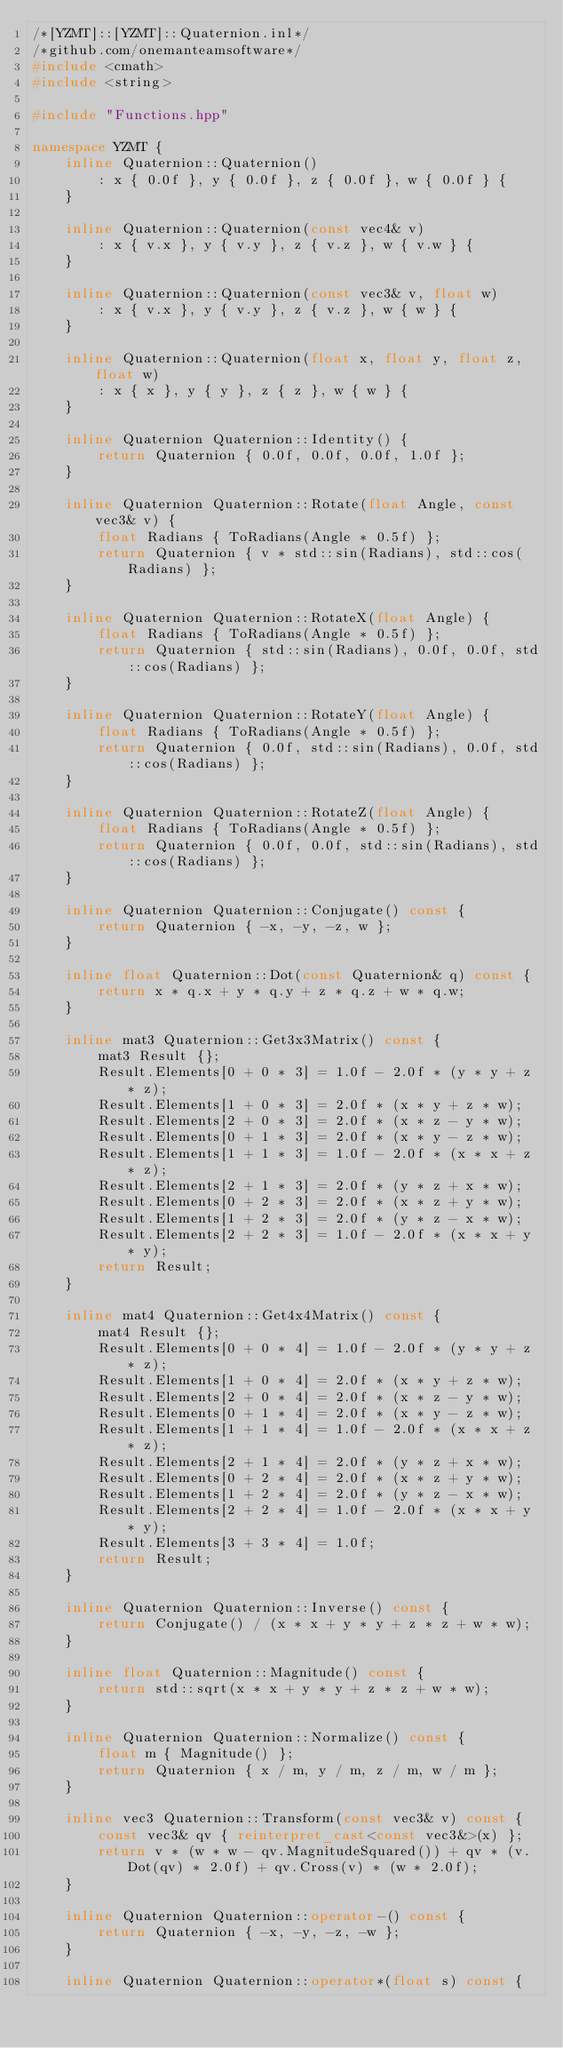Convert code to text. <code><loc_0><loc_0><loc_500><loc_500><_C++_>/*[YZMT]::[YZMT]::Quaternion.inl*/
/*github.com/onemanteamsoftware*/
#include <cmath>
#include <string>

#include "Functions.hpp"

namespace YZMT {
    inline Quaternion::Quaternion()
        : x { 0.0f }, y { 0.0f }, z { 0.0f }, w { 0.0f } {
    }
    
    inline Quaternion::Quaternion(const vec4& v)
        : x { v.x }, y { v.y }, z { v.z }, w { v.w } {
    }
    
    inline Quaternion::Quaternion(const vec3& v, float w)
        : x { v.x }, y { v.y }, z { v.z }, w { w } {
    }
    
    inline Quaternion::Quaternion(float x, float y, float z, float w)
        : x { x }, y { y }, z { z }, w { w } {
    }
    
    inline Quaternion Quaternion::Identity() {
        return Quaternion { 0.0f, 0.0f, 0.0f, 1.0f };
    }
    
    inline Quaternion Quaternion::Rotate(float Angle, const vec3& v) {
        float Radians { ToRadians(Angle * 0.5f) };
        return Quaternion { v * std::sin(Radians), std::cos(Radians) };
    }
    
    inline Quaternion Quaternion::RotateX(float Angle) {
        float Radians { ToRadians(Angle * 0.5f) };
        return Quaternion { std::sin(Radians), 0.0f, 0.0f, std::cos(Radians) };
    }
    
    inline Quaternion Quaternion::RotateY(float Angle) {
        float Radians { ToRadians(Angle * 0.5f) };
        return Quaternion { 0.0f, std::sin(Radians), 0.0f, std::cos(Radians) };
    }
    
    inline Quaternion Quaternion::RotateZ(float Angle) {
        float Radians { ToRadians(Angle * 0.5f) };
        return Quaternion { 0.0f, 0.0f, std::sin(Radians), std::cos(Radians) };
    }
    
    inline Quaternion Quaternion::Conjugate() const {
        return Quaternion { -x, -y, -z, w };
    }
    
    inline float Quaternion::Dot(const Quaternion& q) const {
        return x * q.x + y * q.y + z * q.z + w * q.w;
    }
    
    inline mat3 Quaternion::Get3x3Matrix() const {
        mat3 Result {};
        Result.Elements[0 + 0 * 3] = 1.0f - 2.0f * (y * y + z * z);
        Result.Elements[1 + 0 * 3] = 2.0f * (x * y + z * w);
        Result.Elements[2 + 0 * 3] = 2.0f * (x * z - y * w);
        Result.Elements[0 + 1 * 3] = 2.0f * (x * y - z * w);
        Result.Elements[1 + 1 * 3] = 1.0f - 2.0f * (x * x + z * z);
        Result.Elements[2 + 1 * 3] = 2.0f * (y * z + x * w);
        Result.Elements[0 + 2 * 3] = 2.0f * (x * z + y * w);
        Result.Elements[1 + 2 * 3] = 2.0f * (y * z - x * w);
        Result.Elements[2 + 2 * 3] = 1.0f - 2.0f * (x * x + y * y);
        return Result;
    }
    
    inline mat4 Quaternion::Get4x4Matrix() const {
        mat4 Result {};
        Result.Elements[0 + 0 * 4] = 1.0f - 2.0f * (y * y + z * z);
        Result.Elements[1 + 0 * 4] = 2.0f * (x * y + z * w);
        Result.Elements[2 + 0 * 4] = 2.0f * (x * z - y * w);
        Result.Elements[0 + 1 * 4] = 2.0f * (x * y - z * w);
        Result.Elements[1 + 1 * 4] = 1.0f - 2.0f * (x * x + z * z);
        Result.Elements[2 + 1 * 4] = 2.0f * (y * z + x * w);
        Result.Elements[0 + 2 * 4] = 2.0f * (x * z + y * w);
        Result.Elements[1 + 2 * 4] = 2.0f * (y * z - x * w);
        Result.Elements[2 + 2 * 4] = 1.0f - 2.0f * (x * x + y * y);
        Result.Elements[3 + 3 * 4] = 1.0f;
        return Result;
    }
    
    inline Quaternion Quaternion::Inverse() const {
        return Conjugate() / (x * x + y * y + z * z + w * w);
    }
    
    inline float Quaternion::Magnitude() const {
        return std::sqrt(x * x + y * y + z * z + w * w);
    }
    
    inline Quaternion Quaternion::Normalize() const {
        float m { Magnitude() };
        return Quaternion { x / m, y / m, z / m, w / m };
    }
    
    inline vec3 Quaternion::Transform(const vec3& v) const {
        const vec3& qv { reinterpret_cast<const vec3&>(x) };
        return v * (w * w - qv.MagnitudeSquared()) + qv * (v.Dot(qv) * 2.0f) + qv.Cross(v) * (w * 2.0f);
    }
    
    inline Quaternion Quaternion::operator-() const {
        return Quaternion { -x, -y, -z, -w };
    }
    
    inline Quaternion Quaternion::operator*(float s) const {</code> 